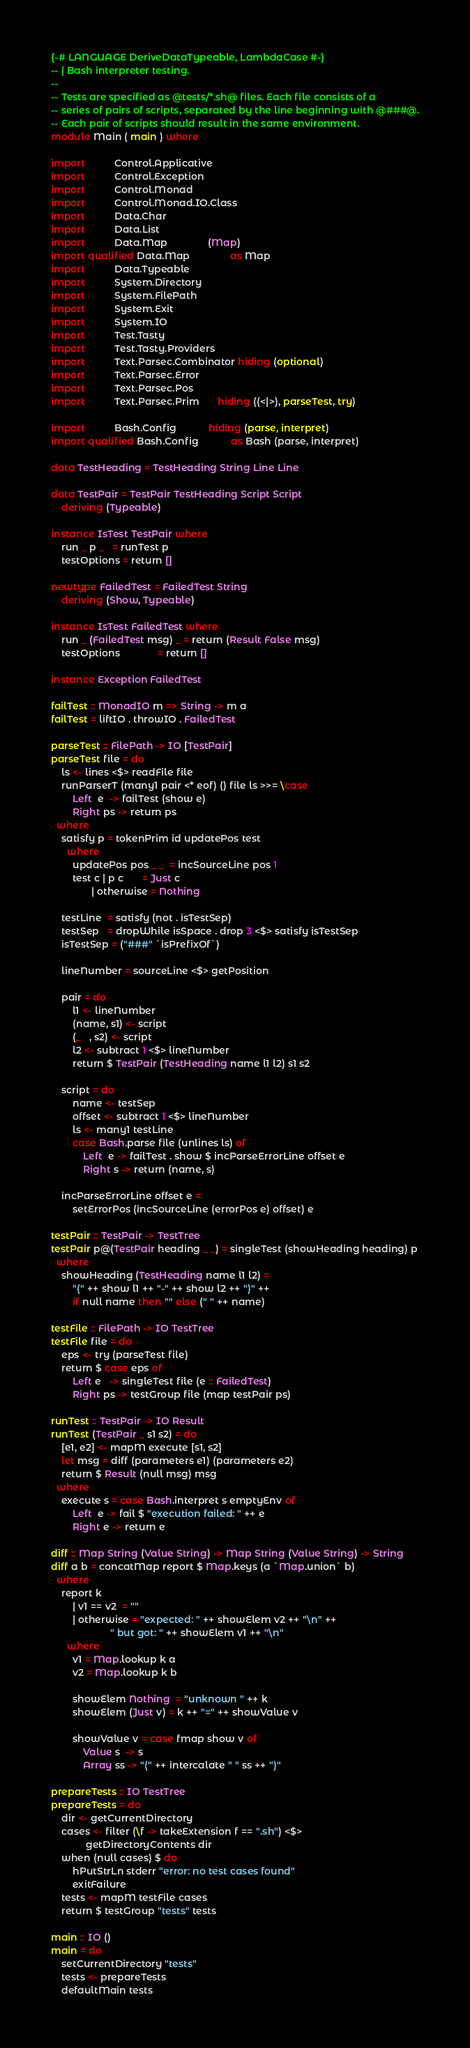<code> <loc_0><loc_0><loc_500><loc_500><_Haskell_>{-# LANGUAGE DeriveDataTypeable, LambdaCase #-}
-- | Bash interpreter testing.
--
-- Tests are specified as @tests/*.sh@ files. Each file consists of a
-- series of pairs of scripts, separated by the line beginning with @###@.
-- Each pair of scripts should result in the same environment.
module Main ( main ) where

import           Control.Applicative
import           Control.Exception
import           Control.Monad
import           Control.Monad.IO.Class
import           Data.Char
import           Data.List
import           Data.Map               (Map)
import qualified Data.Map               as Map
import           Data.Typeable
import           System.Directory
import           System.FilePath
import           System.Exit
import           System.IO
import           Test.Tasty
import           Test.Tasty.Providers
import           Text.Parsec.Combinator hiding (optional)
import           Text.Parsec.Error
import           Text.Parsec.Pos
import           Text.Parsec.Prim       hiding ((<|>), parseTest, try)

import           Bash.Config            hiding (parse, interpret)
import qualified Bash.Config            as Bash (parse, interpret)

data TestHeading = TestHeading String Line Line

data TestPair = TestPair TestHeading Script Script
    deriving (Typeable)

instance IsTest TestPair where
    run _ p _   = runTest p
    testOptions = return []

newtype FailedTest = FailedTest String
    deriving (Show, Typeable)

instance IsTest FailedTest where
    run _ (FailedTest msg) _ = return (Result False msg)
    testOptions              = return []

instance Exception FailedTest

failTest :: MonadIO m => String -> m a
failTest = liftIO . throwIO . FailedTest

parseTest :: FilePath -> IO [TestPair]
parseTest file = do
    ls <- lines <$> readFile file
    runParserT (many1 pair <* eof) () file ls >>= \case
        Left  e  -> failTest (show e)
        Right ps -> return ps
  where
    satisfy p = tokenPrim id updatePos test
      where
        updatePos pos _ _  = incSourceLine pos 1
        test c | p c       = Just c
               | otherwise = Nothing

    testLine  = satisfy (not . isTestSep)
    testSep   = dropWhile isSpace . drop 3 <$> satisfy isTestSep
    isTestSep = ("###" `isPrefixOf`)

    lineNumber = sourceLine <$> getPosition

    pair = do
        l1 <- lineNumber
        (name, s1) <- script
        (_   , s2) <- script
        l2 <- subtract 1 <$> lineNumber
        return $ TestPair (TestHeading name l1 l2) s1 s2

    script = do
        name <- testSep
        offset <- subtract 1 <$> lineNumber
        ls <- many1 testLine
        case Bash.parse file (unlines ls) of
            Left  e -> failTest . show $ incParseErrorLine offset e
            Right s -> return (name, s)

    incParseErrorLine offset e =
        setErrorPos (incSourceLine (errorPos e) offset) e

testPair :: TestPair -> TestTree
testPair p@(TestPair heading _ _) = singleTest (showHeading heading) p
  where
    showHeading (TestHeading name l1 l2) =
        "(" ++ show l1 ++ "-" ++ show l2 ++ ")" ++
        if null name then "" else (" " ++ name)

testFile :: FilePath -> IO TestTree
testFile file = do
    eps <- try (parseTest file)
    return $ case eps of
        Left e   -> singleTest file (e :: FailedTest)
        Right ps -> testGroup file (map testPair ps)

runTest :: TestPair -> IO Result
runTest (TestPair _ s1 s2) = do
    [e1, e2] <- mapM execute [s1, s2]
    let msg = diff (parameters e1) (parameters e2)
    return $ Result (null msg) msg
  where
    execute s = case Bash.interpret s emptyEnv of
        Left  e -> fail $ "execution failed: " ++ e
        Right e -> return e

diff :: Map String (Value String) -> Map String (Value String) -> String
diff a b = concatMap report $ Map.keys (a `Map.union` b)
  where
    report k
        | v1 == v2  = ""
        | otherwise = "expected: " ++ showElem v2 ++ "\n" ++
                      " but got: " ++ showElem v1 ++ "\n"
      where
        v1 = Map.lookup k a
        v2 = Map.lookup k b

        showElem Nothing  = "unknown " ++ k
        showElem (Just v) = k ++ "=" ++ showValue v

        showValue v = case fmap show v of
            Value s  -> s
            Array ss -> "(" ++ intercalate " " ss ++ ")"

prepareTests :: IO TestTree
prepareTests = do
    dir <- getCurrentDirectory
    cases <- filter (\f -> takeExtension f == ".sh") <$>
             getDirectoryContents dir
    when (null cases) $ do
        hPutStrLn stderr "error: no test cases found"
        exitFailure
    tests <- mapM testFile cases
    return $ testGroup "tests" tests

main :: IO ()
main = do
    setCurrentDirectory "tests"
    tests <- prepareTests
    defaultMain tests
</code> 